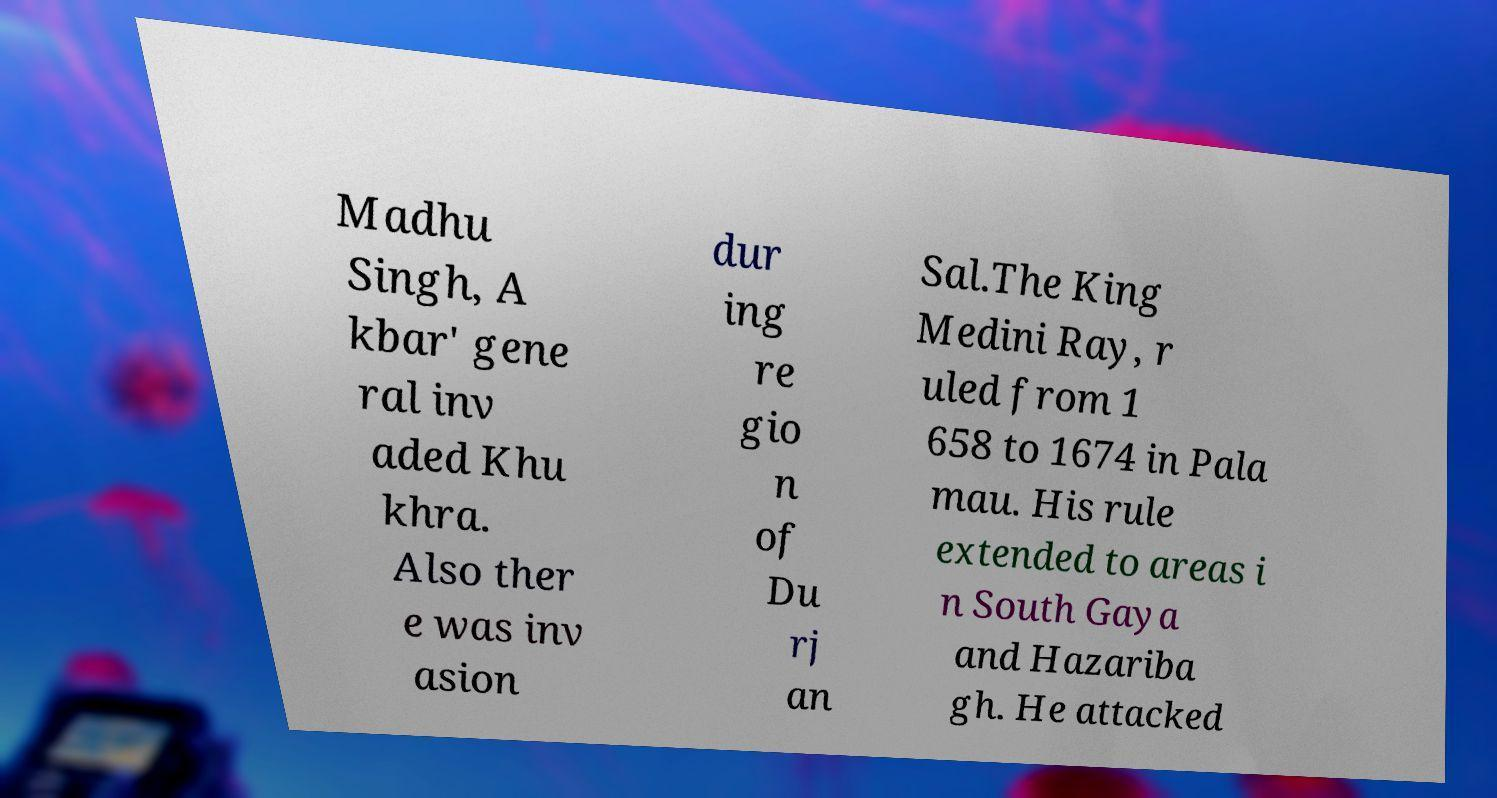What messages or text are displayed in this image? I need them in a readable, typed format. Madhu Singh, A kbar' gene ral inv aded Khu khra. Also ther e was inv asion dur ing re gio n of Du rj an Sal.The King Medini Ray, r uled from 1 658 to 1674 in Pala mau. His rule extended to areas i n South Gaya and Hazariba gh. He attacked 